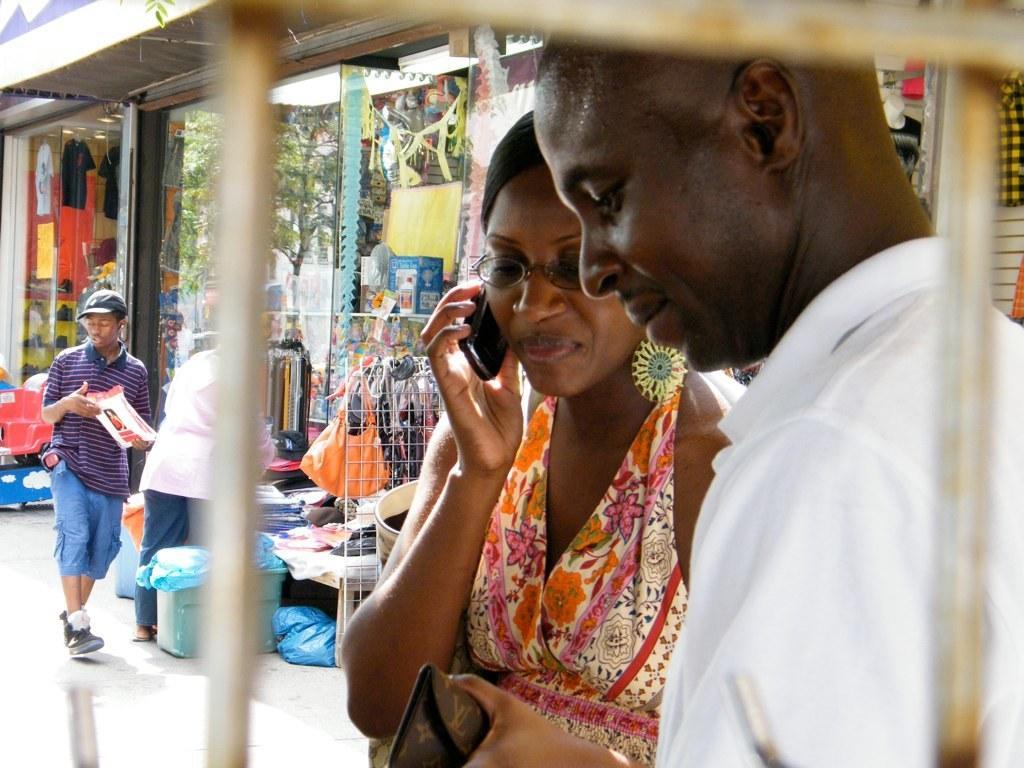How would you summarize this image in a sentence or two? In this image we can see a man and a woman holding a purse and a mobile and wearing a specs. In the back there is a person wearing cap and holding something in the hand. Also there is another person. Also there are shops with many items. And there is a basket with some item. And there is a pole. 